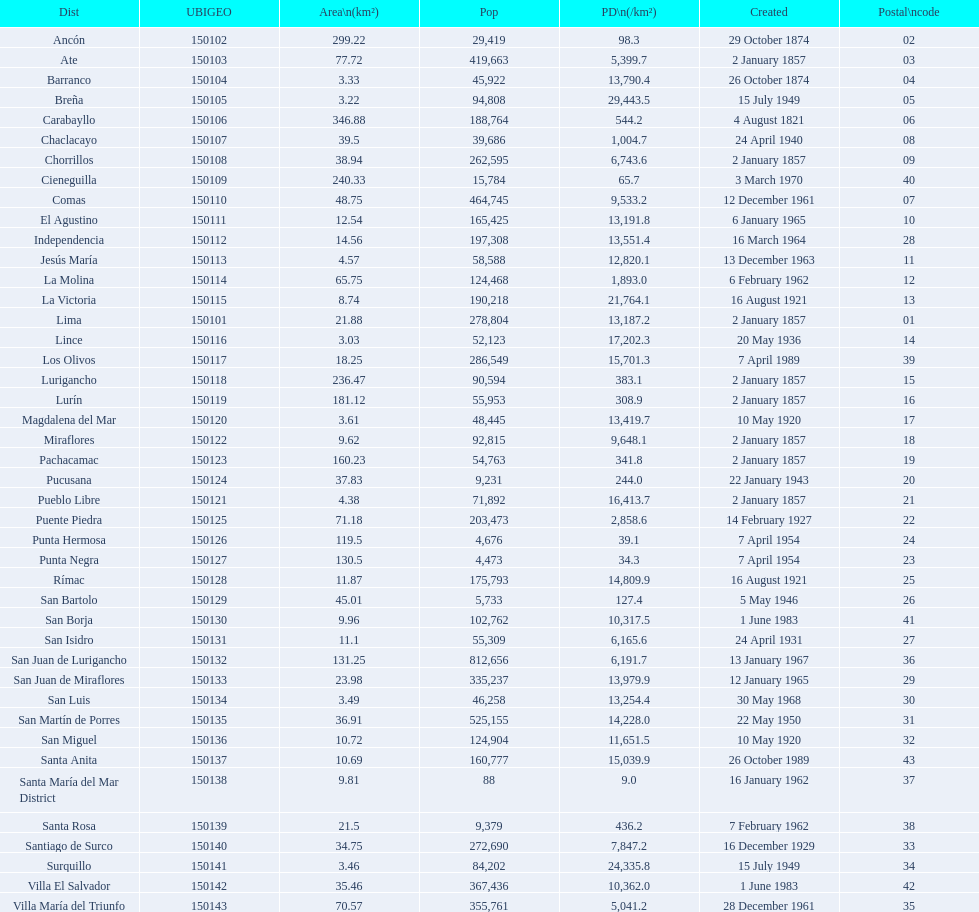I'm looking to parse the entire table for insights. Could you assist me with that? {'header': ['Dist', 'UBIGEO', 'Area\\n(km²)', 'Pop', 'PD\\n(/km²)', 'Created', 'Postal\\ncode'], 'rows': [['Ancón', '150102', '299.22', '29,419', '98.3', '29 October 1874', '02'], ['Ate', '150103', '77.72', '419,663', '5,399.7', '2 January 1857', '03'], ['Barranco', '150104', '3.33', '45,922', '13,790.4', '26 October 1874', '04'], ['Breña', '150105', '3.22', '94,808', '29,443.5', '15 July 1949', '05'], ['Carabayllo', '150106', '346.88', '188,764', '544.2', '4 August 1821', '06'], ['Chaclacayo', '150107', '39.5', '39,686', '1,004.7', '24 April 1940', '08'], ['Chorrillos', '150108', '38.94', '262,595', '6,743.6', '2 January 1857', '09'], ['Cieneguilla', '150109', '240.33', '15,784', '65.7', '3 March 1970', '40'], ['Comas', '150110', '48.75', '464,745', '9,533.2', '12 December 1961', '07'], ['El Agustino', '150111', '12.54', '165,425', '13,191.8', '6 January 1965', '10'], ['Independencia', '150112', '14.56', '197,308', '13,551.4', '16 March 1964', '28'], ['Jesús María', '150113', '4.57', '58,588', '12,820.1', '13 December 1963', '11'], ['La Molina', '150114', '65.75', '124,468', '1,893.0', '6 February 1962', '12'], ['La Victoria', '150115', '8.74', '190,218', '21,764.1', '16 August 1921', '13'], ['Lima', '150101', '21.88', '278,804', '13,187.2', '2 January 1857', '01'], ['Lince', '150116', '3.03', '52,123', '17,202.3', '20 May 1936', '14'], ['Los Olivos', '150117', '18.25', '286,549', '15,701.3', '7 April 1989', '39'], ['Lurigancho', '150118', '236.47', '90,594', '383.1', '2 January 1857', '15'], ['Lurín', '150119', '181.12', '55,953', '308.9', '2 January 1857', '16'], ['Magdalena del Mar', '150120', '3.61', '48,445', '13,419.7', '10 May 1920', '17'], ['Miraflores', '150122', '9.62', '92,815', '9,648.1', '2 January 1857', '18'], ['Pachacamac', '150123', '160.23', '54,763', '341.8', '2 January 1857', '19'], ['Pucusana', '150124', '37.83', '9,231', '244.0', '22 January 1943', '20'], ['Pueblo Libre', '150121', '4.38', '71,892', '16,413.7', '2 January 1857', '21'], ['Puente Piedra', '150125', '71.18', '203,473', '2,858.6', '14 February 1927', '22'], ['Punta Hermosa', '150126', '119.5', '4,676', '39.1', '7 April 1954', '24'], ['Punta Negra', '150127', '130.5', '4,473', '34.3', '7 April 1954', '23'], ['Rímac', '150128', '11.87', '175,793', '14,809.9', '16 August 1921', '25'], ['San Bartolo', '150129', '45.01', '5,733', '127.4', '5 May 1946', '26'], ['San Borja', '150130', '9.96', '102,762', '10,317.5', '1 June 1983', '41'], ['San Isidro', '150131', '11.1', '55,309', '6,165.6', '24 April 1931', '27'], ['San Juan de Lurigancho', '150132', '131.25', '812,656', '6,191.7', '13 January 1967', '36'], ['San Juan de Miraflores', '150133', '23.98', '335,237', '13,979.9', '12 January 1965', '29'], ['San Luis', '150134', '3.49', '46,258', '13,254.4', '30 May 1968', '30'], ['San Martín de Porres', '150135', '36.91', '525,155', '14,228.0', '22 May 1950', '31'], ['San Miguel', '150136', '10.72', '124,904', '11,651.5', '10 May 1920', '32'], ['Santa Anita', '150137', '10.69', '160,777', '15,039.9', '26 October 1989', '43'], ['Santa María del Mar District', '150138', '9.81', '88', '9.0', '16 January 1962', '37'], ['Santa Rosa', '150139', '21.5', '9,379', '436.2', '7 February 1962', '38'], ['Santiago de Surco', '150140', '34.75', '272,690', '7,847.2', '16 December 1929', '33'], ['Surquillo', '150141', '3.46', '84,202', '24,335.8', '15 July 1949', '34'], ['Villa El Salvador', '150142', '35.46', '367,436', '10,362.0', '1 June 1983', '42'], ['Villa María del Triunfo', '150143', '70.57', '355,761', '5,041.2', '28 December 1961', '35']]} How many districts have more than 100,000 people in this city? 21. 